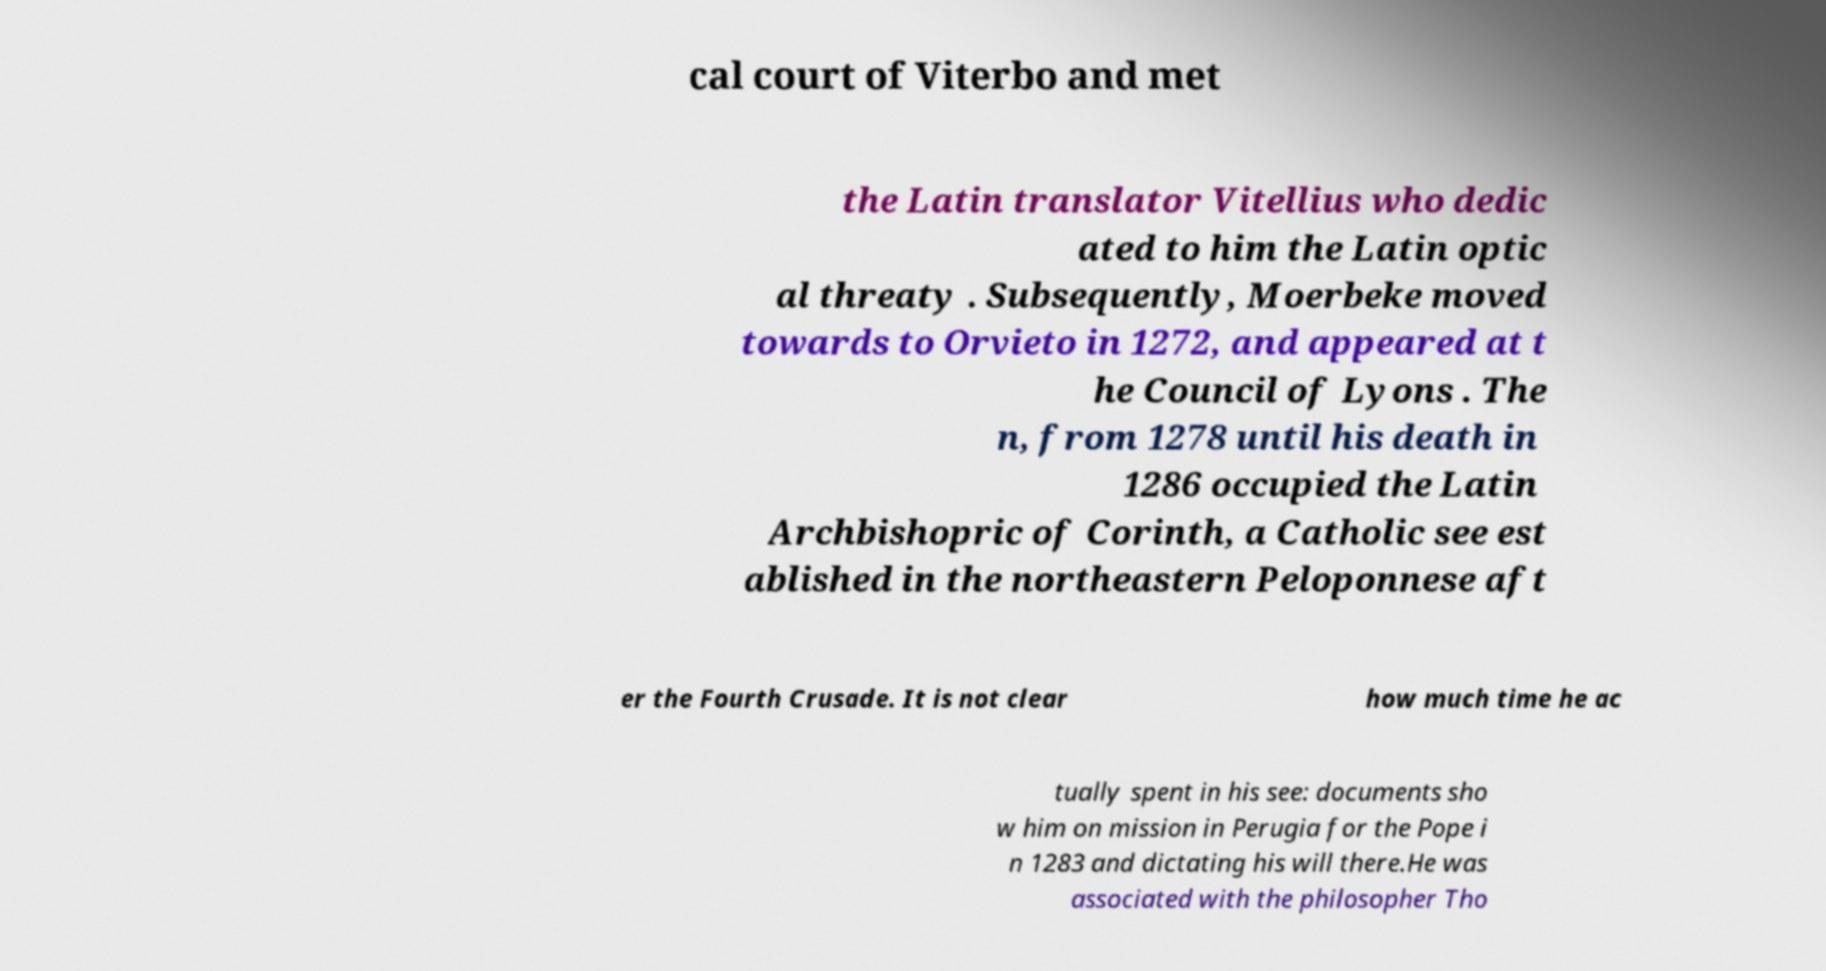Can you read and provide the text displayed in the image?This photo seems to have some interesting text. Can you extract and type it out for me? cal court of Viterbo and met the Latin translator Vitellius who dedic ated to him the Latin optic al threaty . Subsequently, Moerbeke moved towards to Orvieto in 1272, and appeared at t he Council of Lyons . The n, from 1278 until his death in 1286 occupied the Latin Archbishopric of Corinth, a Catholic see est ablished in the northeastern Peloponnese aft er the Fourth Crusade. It is not clear how much time he ac tually spent in his see: documents sho w him on mission in Perugia for the Pope i n 1283 and dictating his will there.He was associated with the philosopher Tho 